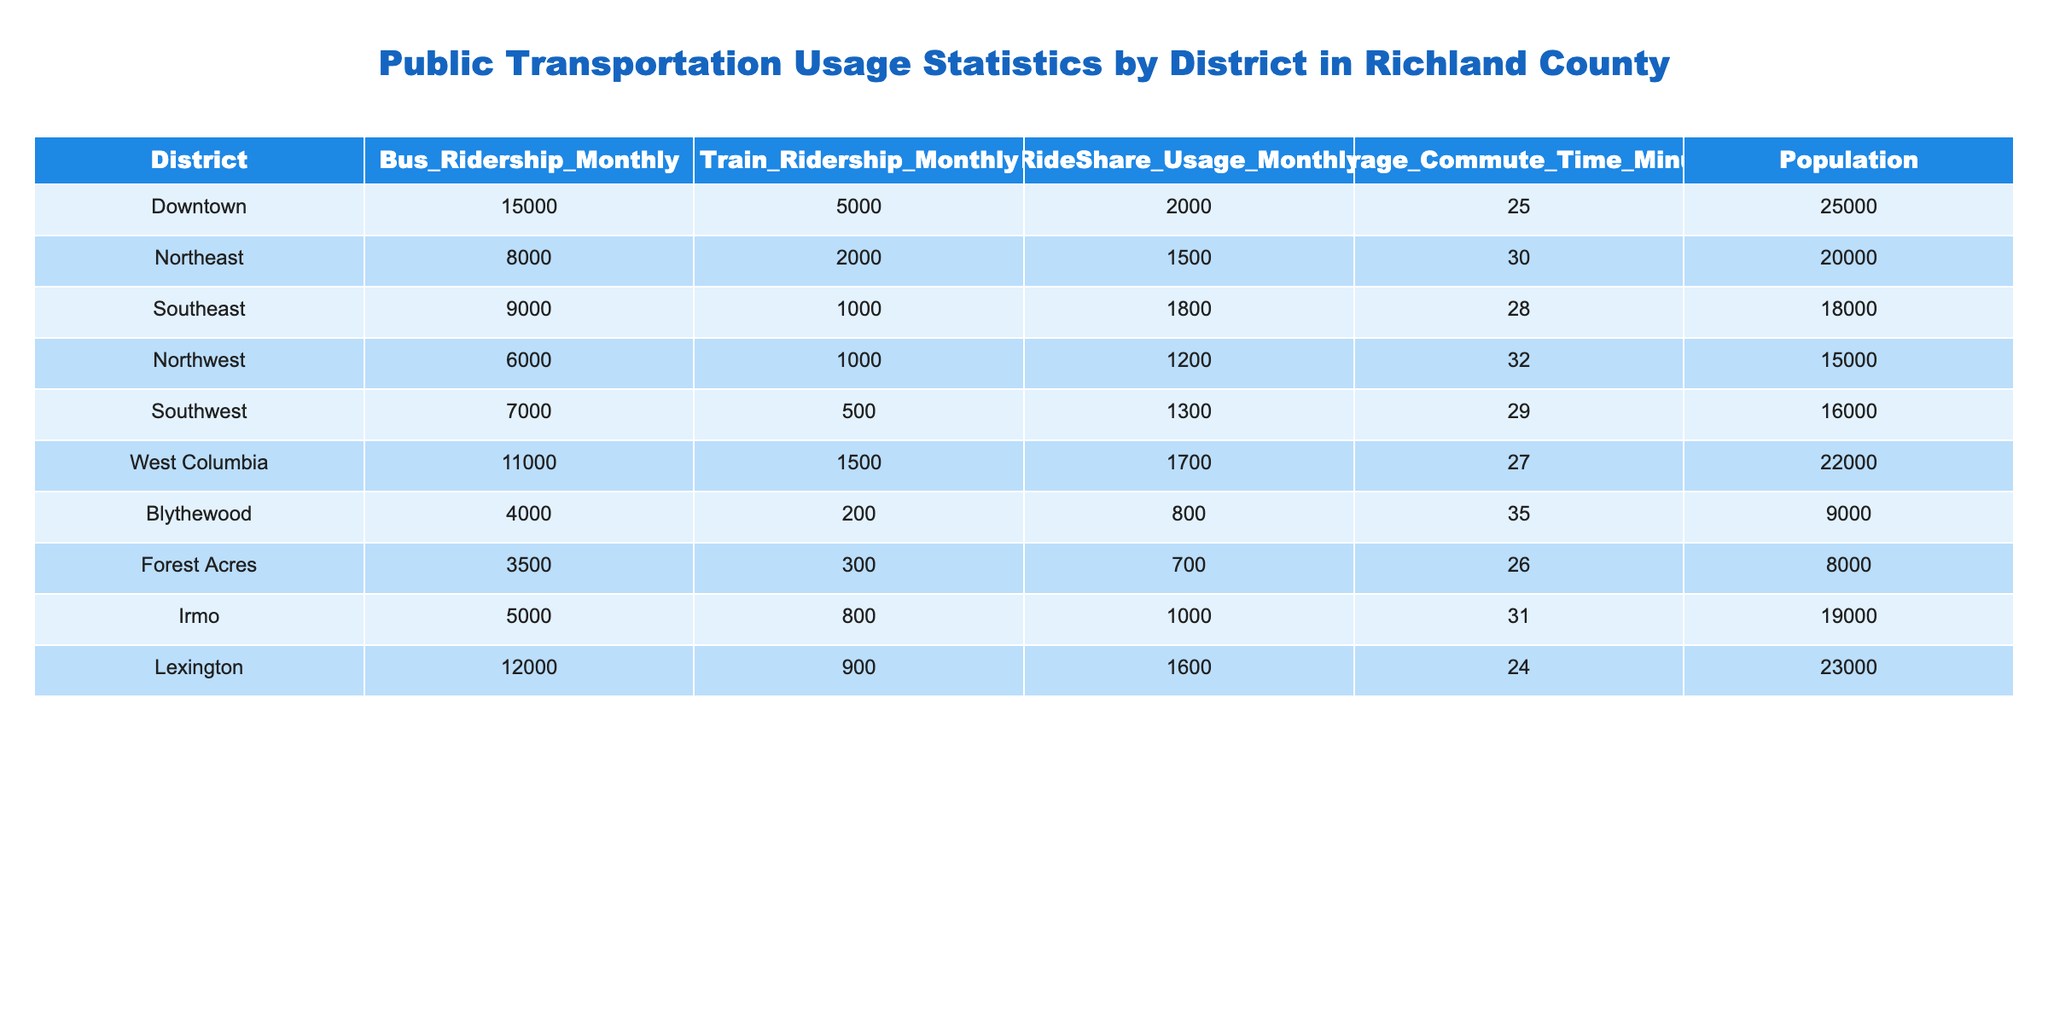What district has the highest bus ridership monthly? The table shows the Bus Ridership Monthly for each district. By comparing the values, Downtown has the highest bus ridership at 15,000.
Answer: Downtown What is the average commute time in the Southwest district? The Average Commute Time for the Southwest district is listed directly in the table as 29 minutes.
Answer: 29 minutes How many total monthly rides are provided by buses, trains, and ride-sharing in Lexington? For Lexington, sum the monthly ridership: Bus (12,000) + Train (900) + RideShare (1,600) = 14,500.
Answer: 14,500 Is the train ridership in the Northeast district greater than that in the Northwest district? The train ridership in Northeast is 2,000 while in Northwest it is 1,000, hence yes, the Northeast has greater train ridership.
Answer: Yes Which district has the lowest overall public transportation usage when combining bus, train, and ride-share ridership? For each district, sum the ridership: Blythewood (4,000 + 200 + 800 = 5,000), Forest Acres (3,500 + 300 + 700 = 4,500), and so on. The one with the lowest combined number is Forest Acres at 4,500.
Answer: Forest Acres Are there more ride-share users in Downtown than in the Southeast district? Downtown has 2,000 ride-share users, while Southeast has 1,800, which shows Downtown has more ride-share users.
Answer: Yes What is the difference in average commute times between the Downtown and Blythewood districts? The Average Commute Time for Downtown is 25 minutes and for Blythewood is 35 minutes. The difference is 35 - 25 = 10 minutes.
Answer: 10 minutes In which district is the train ridership equal to bus ridership? By reviewing the table, there are no districts listed where the train ridership equals the bus ridership, as all values for bus ridership are different from those of train ridership.
Answer: None Which district has a higher population: West Columbia or Irmo? West Columbia has a population of 22,000 and Irmo has 19,000. Therefore, West Columbia has a higher population.
Answer: West Columbia 